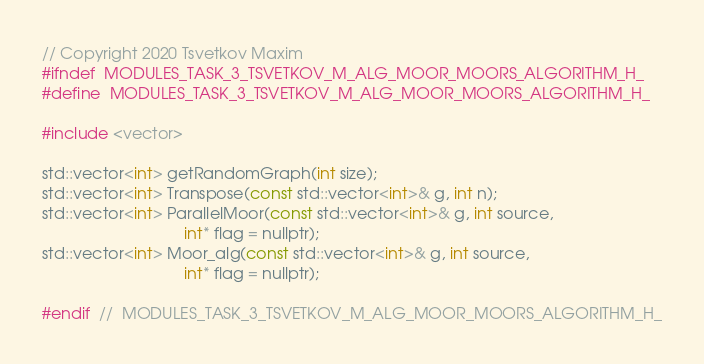Convert code to text. <code><loc_0><loc_0><loc_500><loc_500><_C_>// Copyright 2020 Tsvetkov Maxim
#ifndef  MODULES_TASK_3_TSVETKOV_M_ALG_MOOR_MOORS_ALGORITHM_H_
#define  MODULES_TASK_3_TSVETKOV_M_ALG_MOOR_MOORS_ALGORITHM_H_

#include <vector>

std::vector<int> getRandomGraph(int size);
std::vector<int> Transpose(const std::vector<int>& g, int n);
std::vector<int> ParallelMoor(const std::vector<int>& g, int source,
                                int* flag = nullptr);
std::vector<int> Moor_alg(const std::vector<int>& g, int source,
                                int* flag = nullptr);

#endif  //  MODULES_TASK_3_TSVETKOV_M_ALG_MOOR_MOORS_ALGORITHM_H_
</code> 